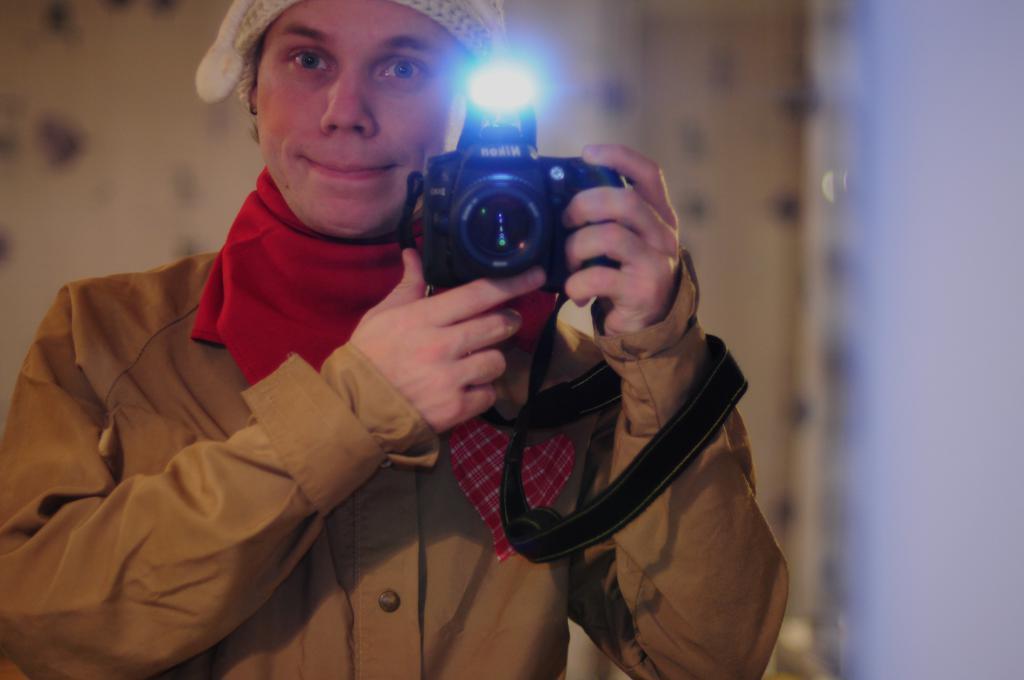How would you summarize this image in a sentence or two? Here we can see a woman on the right and she is holding a camera in her hand. 